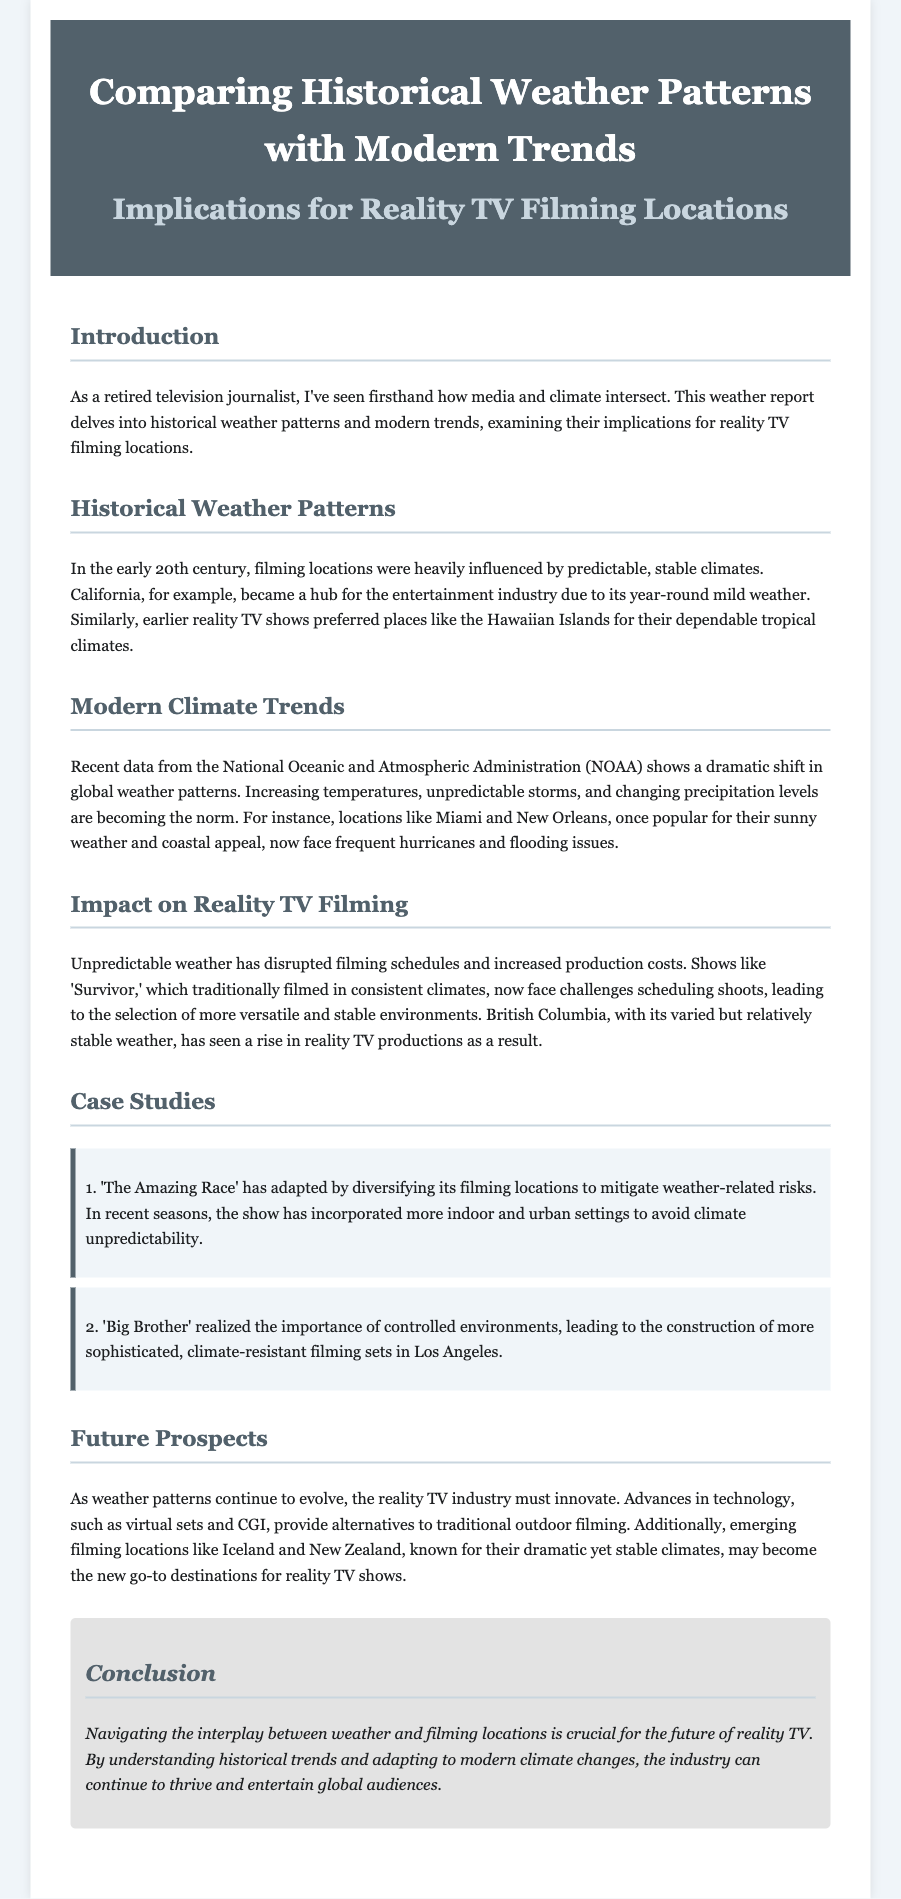What is the primary focus of the report? The report primarily focuses on the intersection of historical weather patterns and modern trends, particularly in relation to reality TV filming locations.
Answer: Weather and reality TV filming locations Which location was historically favored for filming due to its climate? The document mentions California as a hub for the entertainment industry due to its year-round mild weather.
Answer: California What kind of climate trends are highlighted in the report? The report discusses increasing temperatures, unpredictable storms, and changing precipitation levels as modern climate trends.
Answer: Unpredictable storms What filming locations have seen an increase in reality TV productions due to stable weather? British Columbia has been noted for its relatively stable weather which attracted more reality TV productions.
Answer: British Columbia How has 'The Amazing Race' adapted its filming locations? The show has diversified its filming locations to mitigate weather-related risks by incorporating more indoor and urban settings.
Answer: Diversifying filming locations What construction change did 'Big Brother' implement to address weather issues? The show constructed more sophisticated, climate-resistant filming sets in Los Angeles to manage weather impacts effectively.
Answer: Climate-resistant filming sets What is suggested as a future filming location due to its climate? Iceland and New Zealand are mentioned as emerging filming locations known for their dramatic yet stable climates.
Answer: Iceland and New Zealand What weather-related challenge is highlighted for traditional reality shows? Unpredictable weather has disrupted filming schedules and increased production costs, creating challenges for traditional reality shows.
Answer: Disrupted filming schedules What technological advances are suggested for the future of reality TV filming? The report mentions virtual sets and CGI as alternatives to traditional outdoor filming, which could help address climate challenges.
Answer: Virtual sets and CGI 